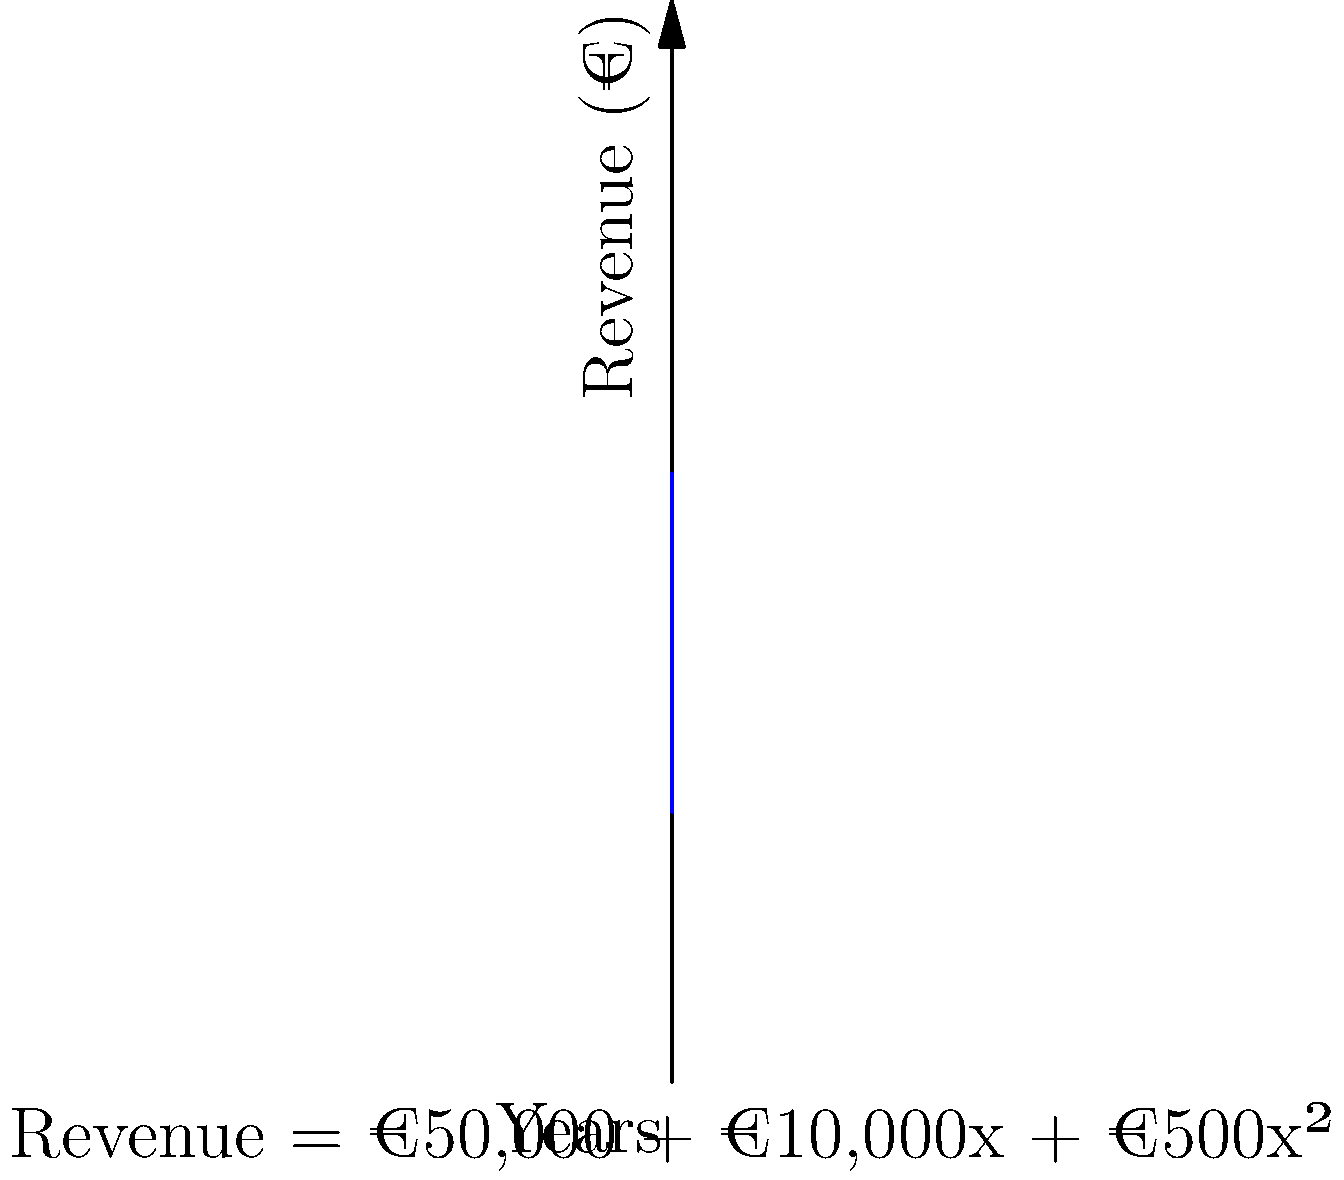The revenue growth of your English language academy over the past 5 years is represented by the function $R(x) = 50000 + 10000x + 500x^2$, where $R(x)$ is the revenue in euros and $x$ is the number of years since the academy's inception. Calculate the total revenue generated by the academy over these 5 years using the area under the curve method. To calculate the total revenue over 5 years, we need to find the area under the curve from $x=0$ to $x=5$. This can be done using definite integration:

1) The integral of $R(x)$ from 0 to 5 is:

   $$\int_0^5 (50000 + 10000x + 500x^2) dx$$

2) Integrate each term:
   $$[50000x + 5000x^2 + \frac{500}{3}x^3]_0^5$$

3) Evaluate at the upper and lower bounds:
   $$(50000(5) + 5000(5^2) + \frac{500}{3}(5^3)) - (50000(0) + 5000(0^2) + \frac{500}{3}(0^3))$$

4) Simplify:
   $$(250000 + 125000 + \frac{500}{3}(125)) - 0$$
   
   $$= 250000 + 125000 + 20833.33$$
   
   $$= 395833.33$$

Therefore, the total revenue over 5 years is approximately €395,833.33.
Answer: €395,833.33 